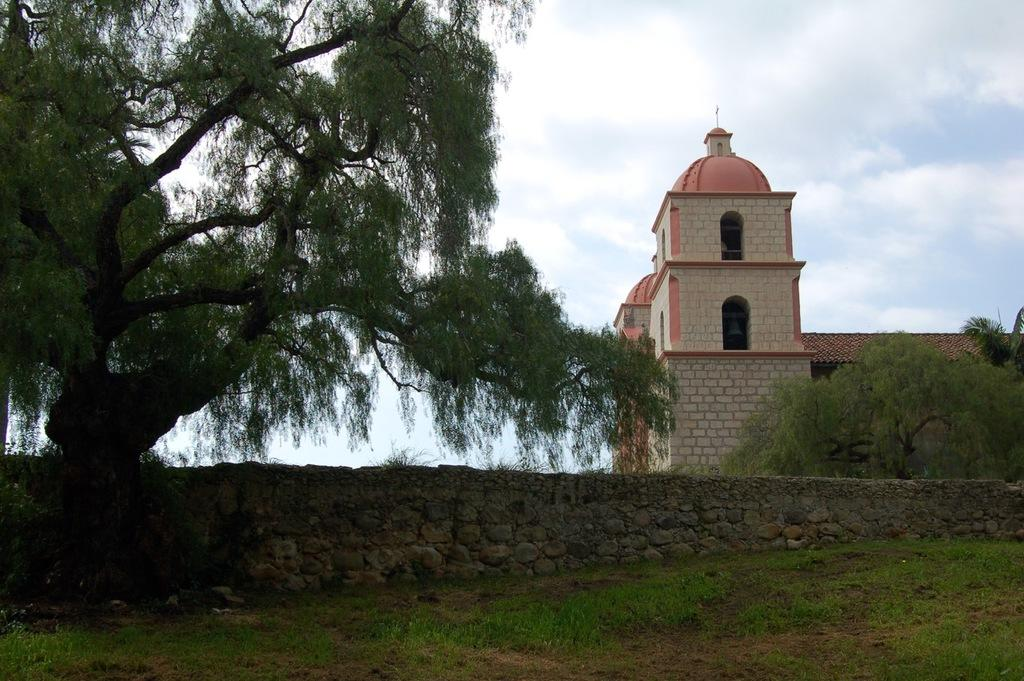What type of vegetation can be seen in the image? There are trees in the image. What type of structure is present in the image? There is a building in the image. What type of barrier is visible in the image? There is a wall in the image. What type of ground cover is present in the image? There is grass on the ground in the image. How would you describe the sky in the image? The sky is blue and cloudy in the image. What is the price of the net in the image? There is no net present in the image, so it is not possible to determine its price. 